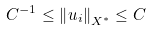Convert formula to latex. <formula><loc_0><loc_0><loc_500><loc_500>C ^ { - 1 } \leq \left \| u _ { i } \right \| _ { X ^ { \ast } } \leq C</formula> 